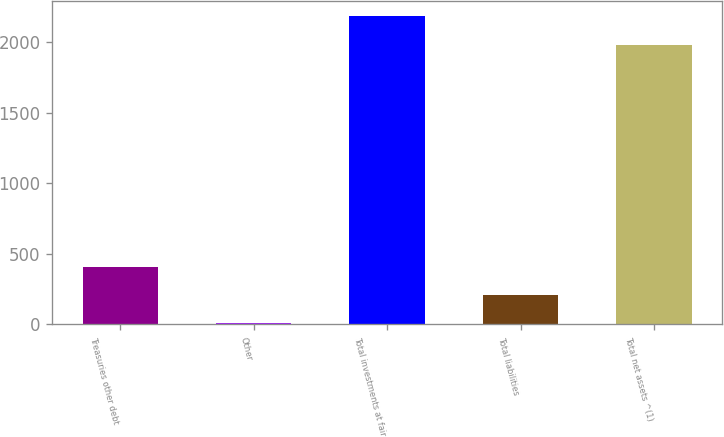Convert chart. <chart><loc_0><loc_0><loc_500><loc_500><bar_chart><fcel>Treasuries other debt<fcel>Other<fcel>Total investments at fair<fcel>Total liabilities<fcel>Total net assets ^(1)<nl><fcel>404.8<fcel>8<fcel>2180.4<fcel>206.4<fcel>1982<nl></chart> 